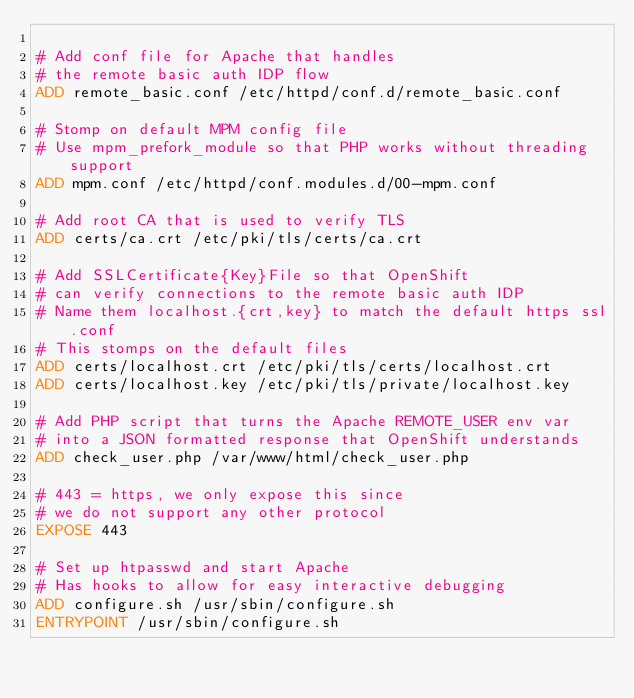Convert code to text. <code><loc_0><loc_0><loc_500><loc_500><_Dockerfile_>
# Add conf file for Apache that handles
# the remote basic auth IDP flow
ADD remote_basic.conf /etc/httpd/conf.d/remote_basic.conf

# Stomp on default MPM config file
# Use mpm_prefork_module so that PHP works without threading support
ADD mpm.conf /etc/httpd/conf.modules.d/00-mpm.conf

# Add root CA that is used to verify TLS
ADD certs/ca.crt /etc/pki/tls/certs/ca.crt

# Add SSLCertificate{Key}File so that OpenShift
# can verify connections to the remote basic auth IDP
# Name them localhost.{crt,key} to match the default https ssl.conf
# This stomps on the default files
ADD certs/localhost.crt /etc/pki/tls/certs/localhost.crt
ADD certs/localhost.key /etc/pki/tls/private/localhost.key

# Add PHP script that turns the Apache REMOTE_USER env var
# into a JSON formatted response that OpenShift understands
ADD check_user.php /var/www/html/check_user.php

# 443 = https, we only expose this since
# we do not support any other protocol
EXPOSE 443

# Set up htpasswd and start Apache
# Has hooks to allow for easy interactive debugging
ADD configure.sh /usr/sbin/configure.sh
ENTRYPOINT /usr/sbin/configure.sh
</code> 